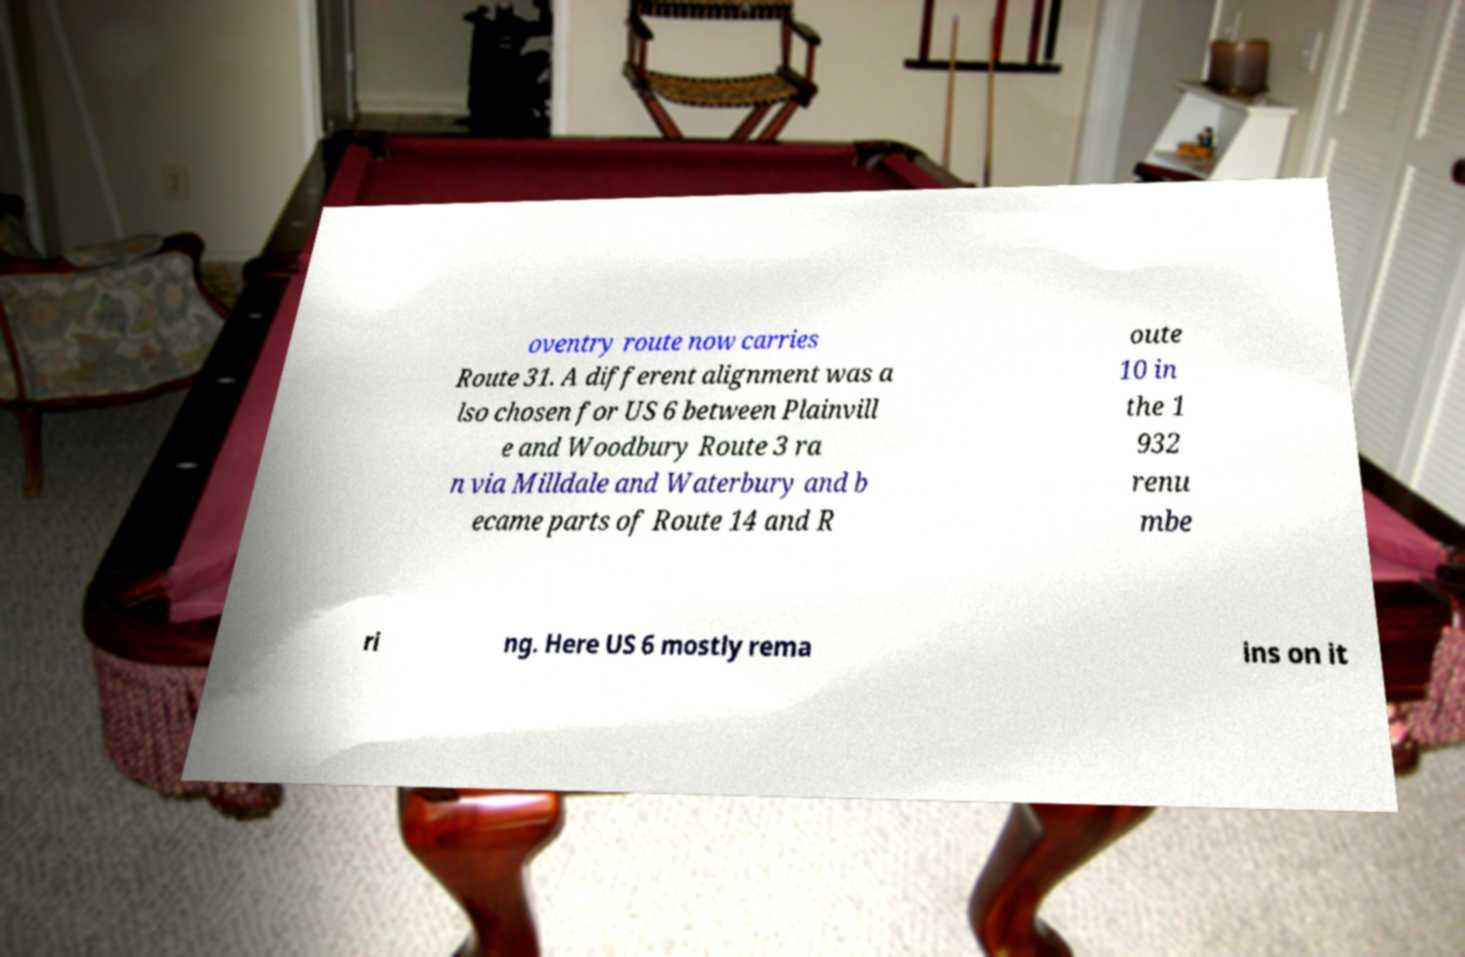What messages or text are displayed in this image? I need them in a readable, typed format. oventry route now carries Route 31. A different alignment was a lso chosen for US 6 between Plainvill e and Woodbury Route 3 ra n via Milldale and Waterbury and b ecame parts of Route 14 and R oute 10 in the 1 932 renu mbe ri ng. Here US 6 mostly rema ins on it 